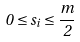<formula> <loc_0><loc_0><loc_500><loc_500>0 \leq s _ { i } \leq \frac { m } { 2 }</formula> 